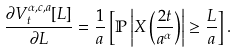Convert formula to latex. <formula><loc_0><loc_0><loc_500><loc_500>\frac { \partial V _ { t } ^ { \alpha , c , a } [ L ] } { \partial L } = \frac { 1 } { a } \left [ \mathbb { P } \left | X \left ( \frac { 2 t } { a ^ { \alpha } } \right ) \right | \geq \frac { L } { a } \right ] .</formula> 